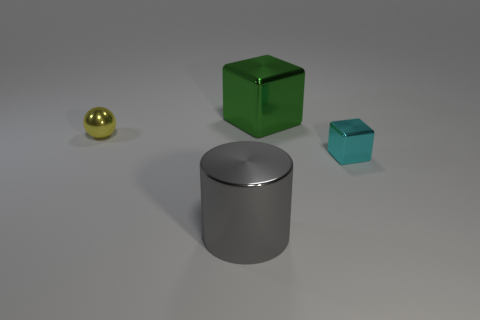The metal thing that is to the right of the large gray metallic object and in front of the shiny sphere is what color?
Keep it short and to the point. Cyan. What number of blocks are either small yellow things or gray metal things?
Offer a terse response. 0. There is a gray metallic thing; is it the same shape as the small thing to the left of the big green thing?
Give a very brief answer. No. What size is the shiny object that is both in front of the big green metal block and to the right of the big gray shiny thing?
Offer a terse response. Small. What shape is the large green shiny object?
Give a very brief answer. Cube. There is a big thing in front of the small sphere; are there any big gray cylinders on the right side of it?
Keep it short and to the point. No. How many big green blocks are in front of the small metal object that is on the left side of the large gray cylinder?
Offer a terse response. 0. There is a cyan block that is the same size as the shiny sphere; what is its material?
Offer a terse response. Metal. Is the shape of the big object behind the cyan metal cube the same as  the big gray shiny object?
Ensure brevity in your answer.  No. Is the number of tiny cyan shiny things left of the green shiny thing greater than the number of small blocks behind the yellow ball?
Make the answer very short. No. 